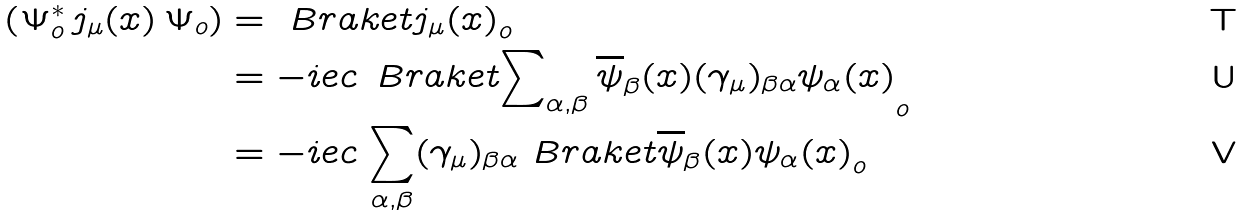Convert formula to latex. <formula><loc_0><loc_0><loc_500><loc_500>\left ( \Psi ^ { * } _ { o } \, j _ { \mu } ( x ) \, \Psi _ { o } \right ) & = \ B r a k e t { j _ { \mu } ( x ) } _ { o } \\ & = - i e c \, \ B r a k e t { \sum \nolimits _ { \alpha , \beta } \overline { \psi } _ { \beta } ( x ) ( \gamma _ { \mu } ) _ { \beta \alpha } \psi _ { \alpha } ( x ) } _ { o } \\ & = - i e c \, \sum _ { \alpha , \beta } ( \gamma _ { \mu } ) _ { \beta \alpha } \ B r a k e t { \overline { \psi } _ { \beta } ( x ) \psi _ { \alpha } ( x ) } _ { o }</formula> 